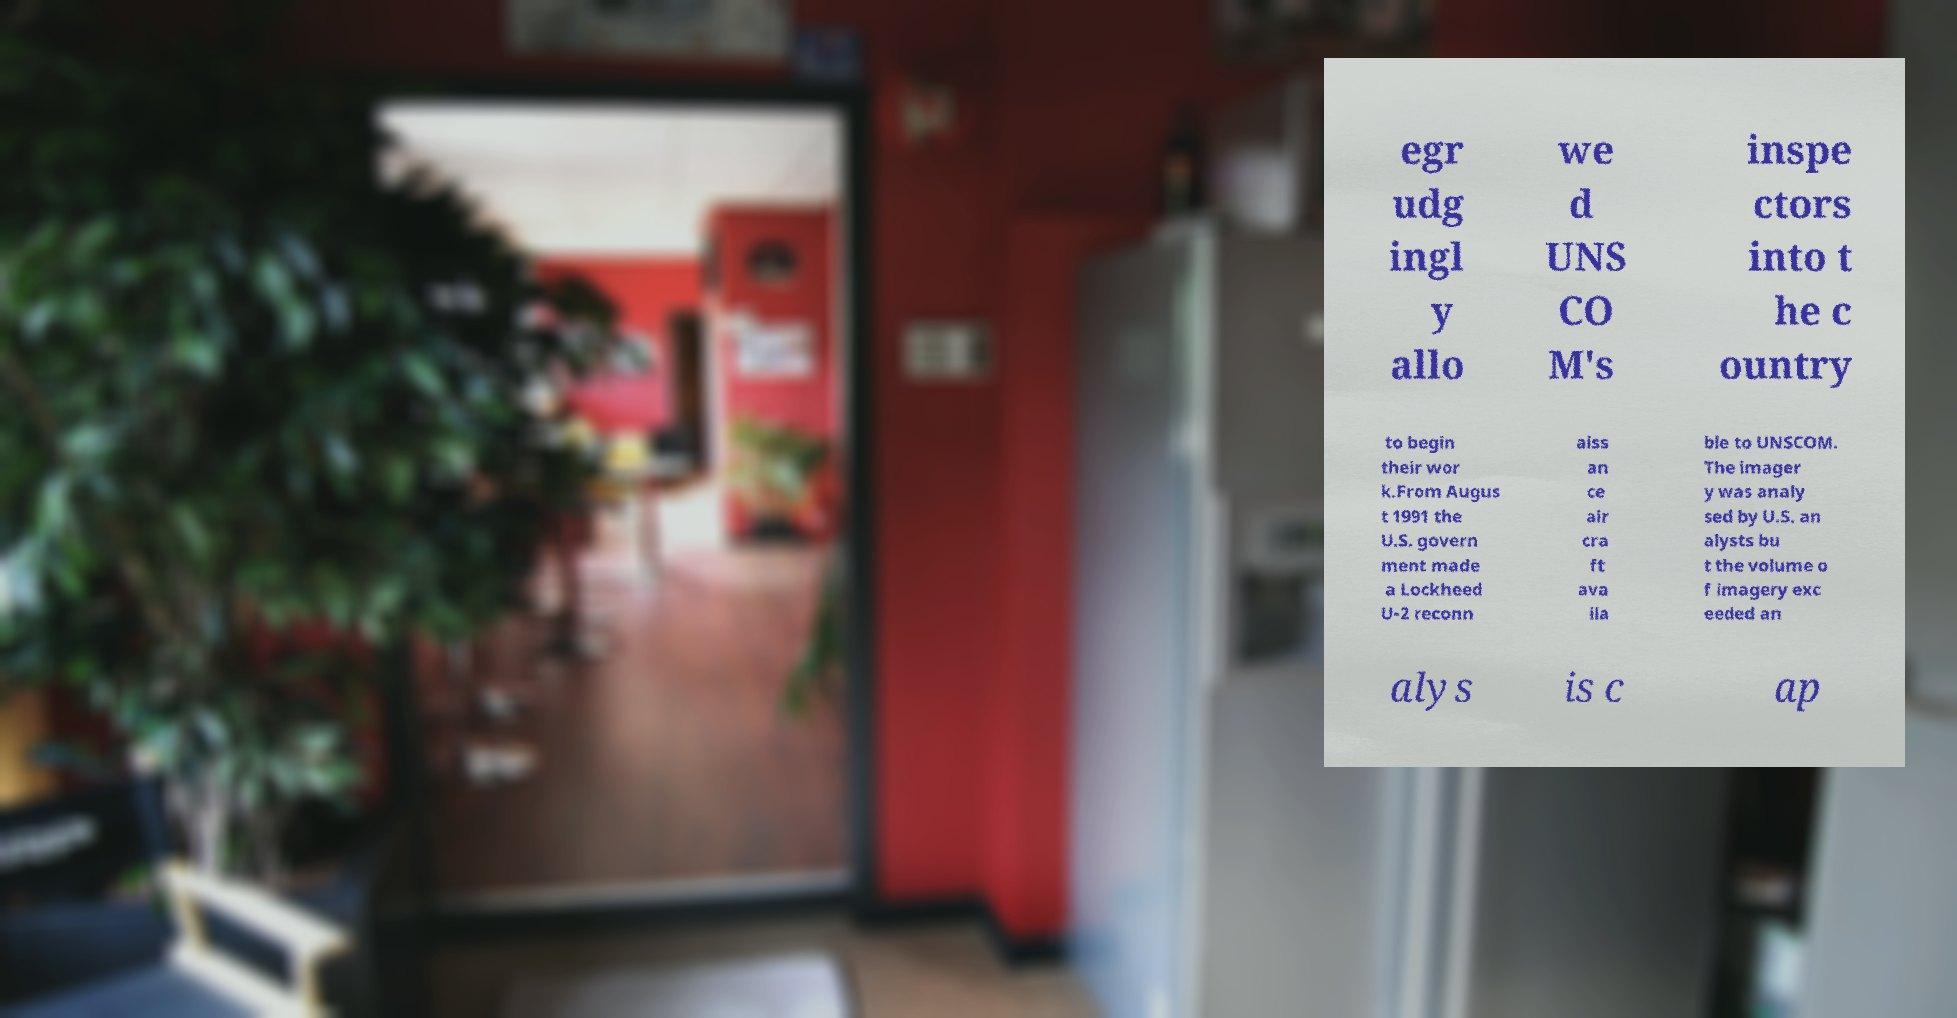I need the written content from this picture converted into text. Can you do that? egr udg ingl y allo we d UNS CO M's inspe ctors into t he c ountry to begin their wor k.From Augus t 1991 the U.S. govern ment made a Lockheed U-2 reconn aiss an ce air cra ft ava ila ble to UNSCOM. The imager y was analy sed by U.S. an alysts bu t the volume o f imagery exc eeded an alys is c ap 